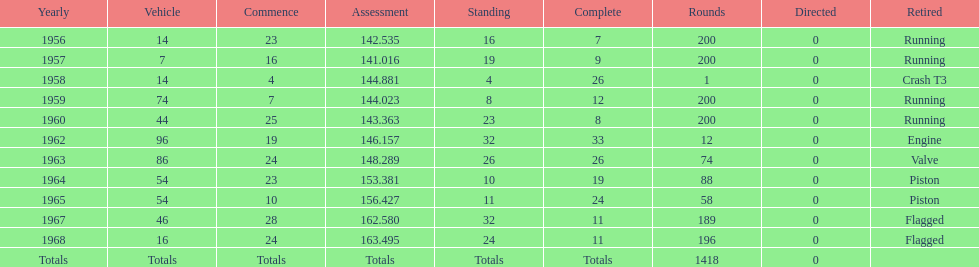What was the last year that it finished the race? 1968. Can you parse all the data within this table? {'header': ['Yearly', 'Vehicle', 'Commence', 'Assessment', 'Standing', 'Complete', 'Rounds', 'Directed', 'Retired'], 'rows': [['1956', '14', '23', '142.535', '16', '7', '200', '0', 'Running'], ['1957', '7', '16', '141.016', '19', '9', '200', '0', 'Running'], ['1958', '14', '4', '144.881', '4', '26', '1', '0', 'Crash T3'], ['1959', '74', '7', '144.023', '8', '12', '200', '0', 'Running'], ['1960', '44', '25', '143.363', '23', '8', '200', '0', 'Running'], ['1962', '96', '19', '146.157', '32', '33', '12', '0', 'Engine'], ['1963', '86', '24', '148.289', '26', '26', '74', '0', 'Valve'], ['1964', '54', '23', '153.381', '10', '19', '88', '0', 'Piston'], ['1965', '54', '10', '156.427', '11', '24', '58', '0', 'Piston'], ['1967', '46', '28', '162.580', '32', '11', '189', '0', 'Flagged'], ['1968', '16', '24', '163.495', '24', '11', '196', '0', 'Flagged'], ['Totals', 'Totals', 'Totals', 'Totals', 'Totals', 'Totals', '1418', '0', '']]} 